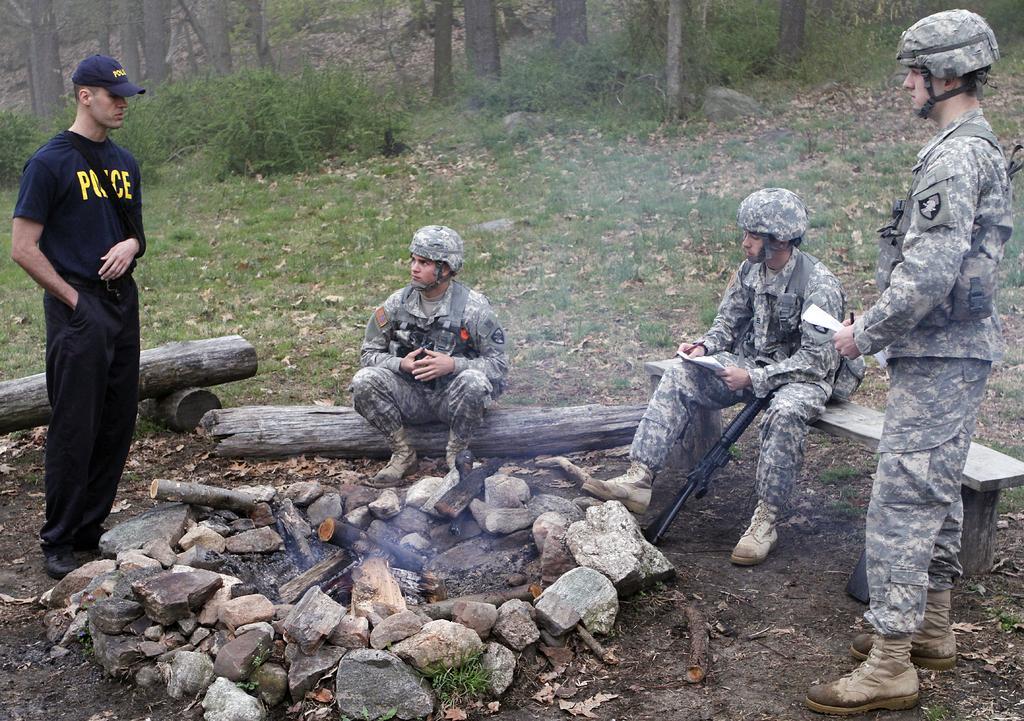Could you give a brief overview of what you see in this image? In the foreground of this image, there are stones around the fire wood and also there are people, two are standing and two are sitting around the stones where two men are holding papers and pens and also we can see a gun, grass and trees at the top. 